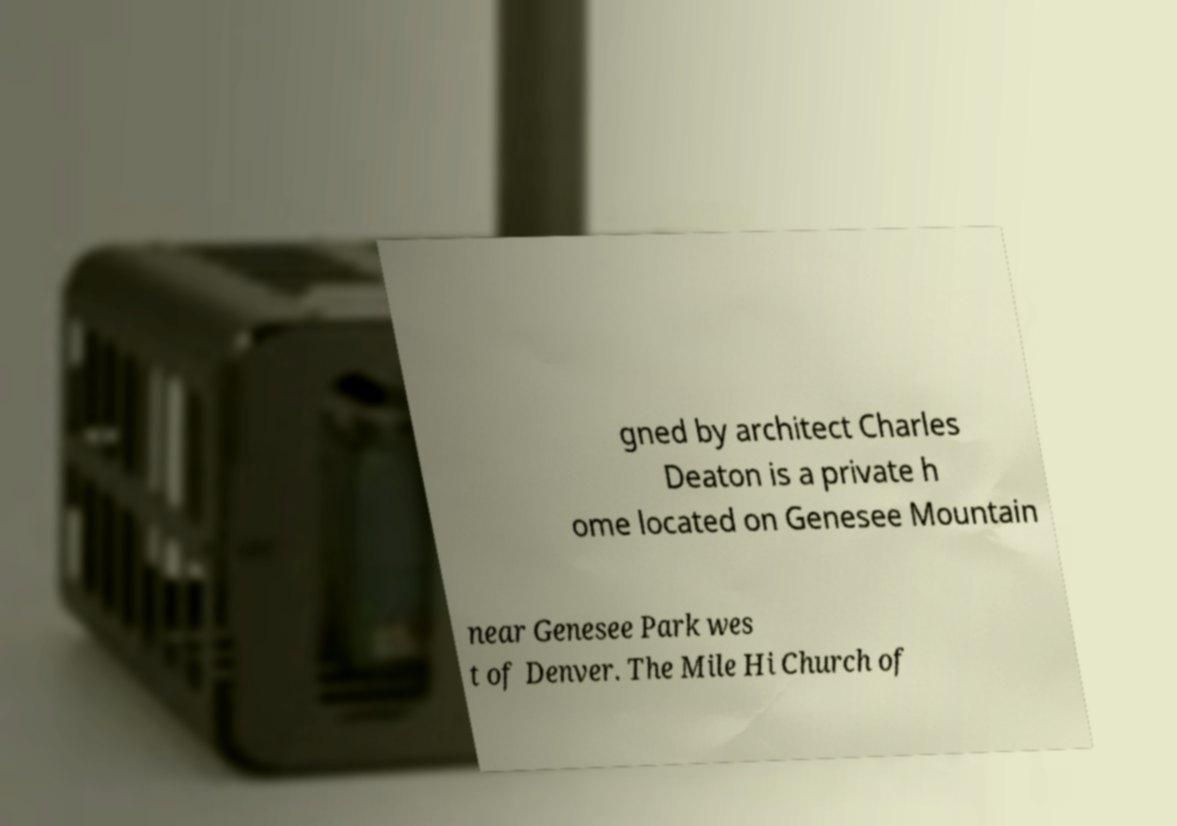Can you read and provide the text displayed in the image?This photo seems to have some interesting text. Can you extract and type it out for me? gned by architect Charles Deaton is a private h ome located on Genesee Mountain near Genesee Park wes t of Denver. The Mile Hi Church of 